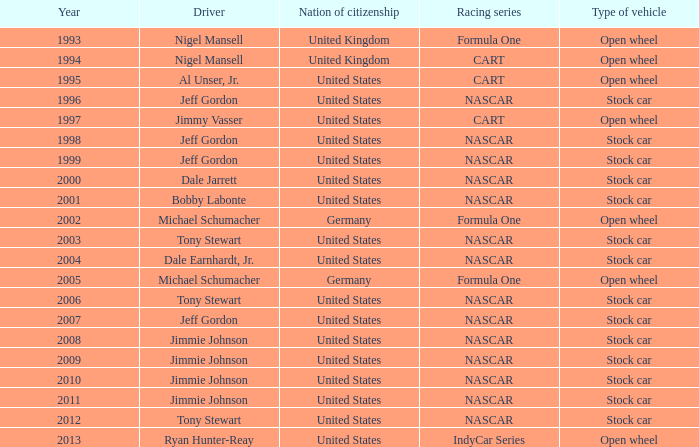Which driver possesses a stock car automobile from 1999? Jeff Gordon. 